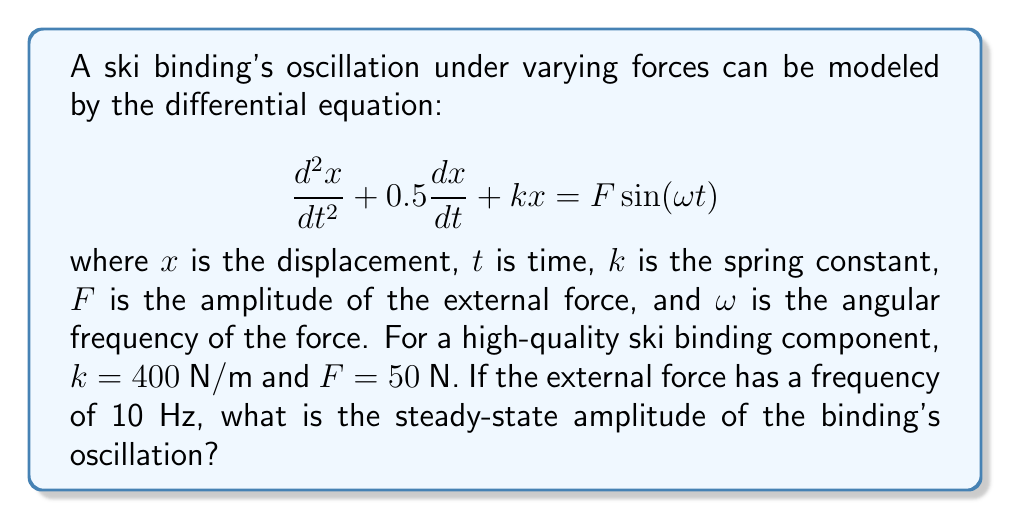Can you answer this question? To solve this problem, we'll follow these steps:

1) First, we need to convert the frequency from Hz to rad/s:
   $\omega = 2\pi f = 2\pi(10) = 20\pi$ rad/s

2) The steady-state solution for a forced oscillation has the form:
   $x(t) = A\sin(\omega t - \phi)$
   where $A$ is the amplitude we're looking for.

3) For a system described by the equation:
   $$\frac{d^2x}{dt^2} + 2\beta\frac{dx}{dt} + \omega_0^2x = F_0\sin(\omega t)$$
   The amplitude $A$ is given by:
   $$A = \frac{F_0}{\sqrt{(\omega_0^2 - \omega^2)^2 + 4\beta^2\omega^2}}$$

4) In our case:
   $2\beta = 0.5$, so $\beta = 0.25$
   $\omega_0^2 = k = 400$, so $\omega_0 = 20$
   $F_0 = F = 50$
   $\omega = 20\pi$

5) Substituting these values:
   $$A = \frac{50}{\sqrt{(400 - (20\pi)^2)^2 + 4(0.25)^2(20\pi)^2}}$$

6) Calculating:
   $$A = \frac{50}{\sqrt{(-1579.79)^2 + 986.96^2}} = \frac{50}{\sqrt{3425078.28}} = 0.0270 \text{ m}$$

7) Converting to millimeters:
   $A = 0.0270 \text{ m} \times 1000 = 27.0 \text{ mm}$
Answer: 27.0 mm 